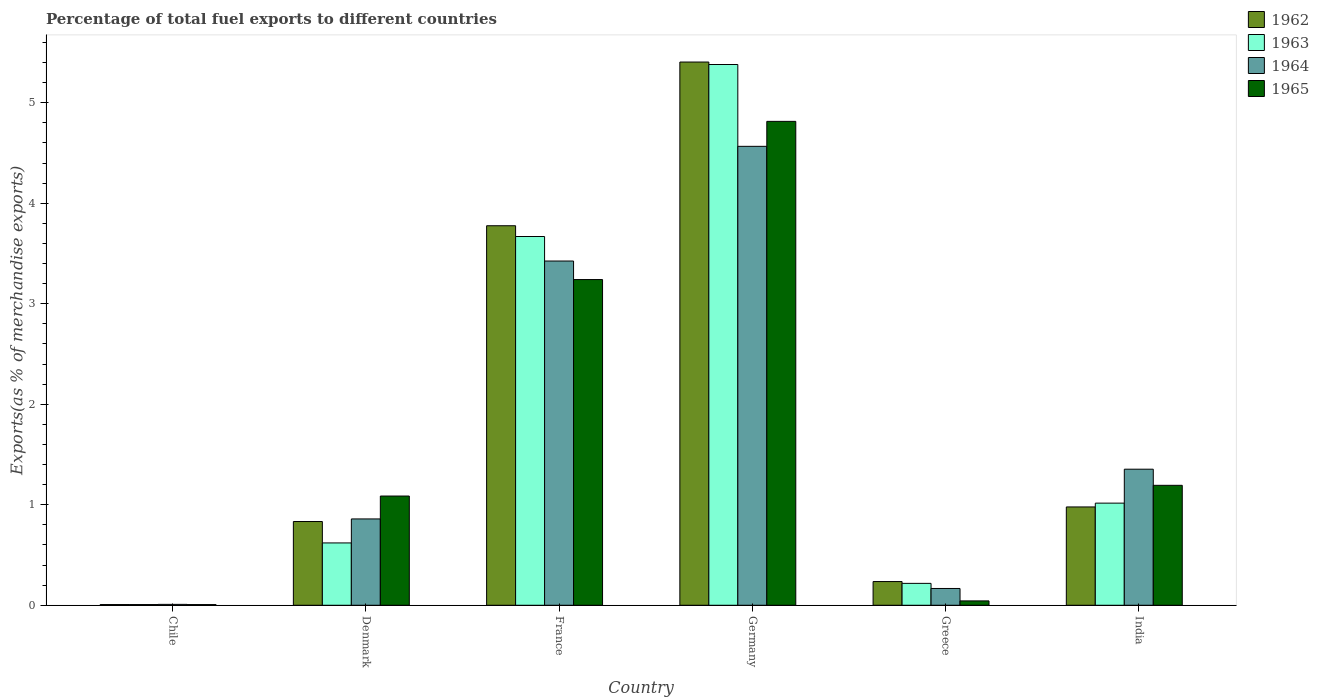How many groups of bars are there?
Provide a succinct answer. 6. Are the number of bars per tick equal to the number of legend labels?
Ensure brevity in your answer.  Yes. Are the number of bars on each tick of the X-axis equal?
Offer a very short reply. Yes. How many bars are there on the 1st tick from the left?
Give a very brief answer. 4. In how many cases, is the number of bars for a given country not equal to the number of legend labels?
Your answer should be compact. 0. What is the percentage of exports to different countries in 1965 in Denmark?
Make the answer very short. 1.09. Across all countries, what is the maximum percentage of exports to different countries in 1965?
Offer a very short reply. 4.81. Across all countries, what is the minimum percentage of exports to different countries in 1965?
Your response must be concise. 0.01. In which country was the percentage of exports to different countries in 1963 maximum?
Keep it short and to the point. Germany. What is the total percentage of exports to different countries in 1962 in the graph?
Keep it short and to the point. 11.24. What is the difference between the percentage of exports to different countries in 1964 in France and that in Greece?
Offer a terse response. 3.26. What is the difference between the percentage of exports to different countries in 1965 in Chile and the percentage of exports to different countries in 1962 in Germany?
Your answer should be compact. -5.4. What is the average percentage of exports to different countries in 1964 per country?
Offer a very short reply. 1.73. What is the difference between the percentage of exports to different countries of/in 1965 and percentage of exports to different countries of/in 1963 in Chile?
Keep it short and to the point. -0. In how many countries, is the percentage of exports to different countries in 1962 greater than 0.8 %?
Provide a succinct answer. 4. What is the ratio of the percentage of exports to different countries in 1962 in Denmark to that in France?
Ensure brevity in your answer.  0.22. Is the percentage of exports to different countries in 1965 in Greece less than that in India?
Make the answer very short. Yes. Is the difference between the percentage of exports to different countries in 1965 in France and India greater than the difference between the percentage of exports to different countries in 1963 in France and India?
Provide a succinct answer. No. What is the difference between the highest and the second highest percentage of exports to different countries in 1962?
Your answer should be compact. -2.8. What is the difference between the highest and the lowest percentage of exports to different countries in 1964?
Provide a succinct answer. 4.56. In how many countries, is the percentage of exports to different countries in 1965 greater than the average percentage of exports to different countries in 1965 taken over all countries?
Provide a succinct answer. 2. What does the 3rd bar from the left in India represents?
Provide a short and direct response. 1964. What does the 2nd bar from the right in Greece represents?
Keep it short and to the point. 1964. Are all the bars in the graph horizontal?
Offer a very short reply. No. How many countries are there in the graph?
Your answer should be very brief. 6. What is the difference between two consecutive major ticks on the Y-axis?
Your answer should be compact. 1. Are the values on the major ticks of Y-axis written in scientific E-notation?
Your response must be concise. No. Does the graph contain grids?
Your answer should be very brief. No. Where does the legend appear in the graph?
Ensure brevity in your answer.  Top right. What is the title of the graph?
Offer a terse response. Percentage of total fuel exports to different countries. What is the label or title of the Y-axis?
Keep it short and to the point. Exports(as % of merchandise exports). What is the Exports(as % of merchandise exports) of 1962 in Chile?
Keep it short and to the point. 0.01. What is the Exports(as % of merchandise exports) in 1963 in Chile?
Ensure brevity in your answer.  0.01. What is the Exports(as % of merchandise exports) in 1964 in Chile?
Give a very brief answer. 0.01. What is the Exports(as % of merchandise exports) in 1965 in Chile?
Give a very brief answer. 0.01. What is the Exports(as % of merchandise exports) of 1962 in Denmark?
Your answer should be compact. 0.83. What is the Exports(as % of merchandise exports) in 1963 in Denmark?
Give a very brief answer. 0.62. What is the Exports(as % of merchandise exports) of 1964 in Denmark?
Your answer should be compact. 0.86. What is the Exports(as % of merchandise exports) of 1965 in Denmark?
Make the answer very short. 1.09. What is the Exports(as % of merchandise exports) of 1962 in France?
Your answer should be compact. 3.78. What is the Exports(as % of merchandise exports) in 1963 in France?
Keep it short and to the point. 3.67. What is the Exports(as % of merchandise exports) of 1964 in France?
Your answer should be very brief. 3.43. What is the Exports(as % of merchandise exports) of 1965 in France?
Your answer should be compact. 3.24. What is the Exports(as % of merchandise exports) in 1962 in Germany?
Keep it short and to the point. 5.4. What is the Exports(as % of merchandise exports) in 1963 in Germany?
Offer a terse response. 5.38. What is the Exports(as % of merchandise exports) in 1964 in Germany?
Give a very brief answer. 4.57. What is the Exports(as % of merchandise exports) in 1965 in Germany?
Make the answer very short. 4.81. What is the Exports(as % of merchandise exports) of 1962 in Greece?
Offer a very short reply. 0.24. What is the Exports(as % of merchandise exports) in 1963 in Greece?
Offer a very short reply. 0.22. What is the Exports(as % of merchandise exports) of 1964 in Greece?
Keep it short and to the point. 0.17. What is the Exports(as % of merchandise exports) in 1965 in Greece?
Offer a terse response. 0.04. What is the Exports(as % of merchandise exports) in 1962 in India?
Ensure brevity in your answer.  0.98. What is the Exports(as % of merchandise exports) in 1963 in India?
Your answer should be compact. 1.02. What is the Exports(as % of merchandise exports) of 1964 in India?
Provide a succinct answer. 1.35. What is the Exports(as % of merchandise exports) in 1965 in India?
Make the answer very short. 1.19. Across all countries, what is the maximum Exports(as % of merchandise exports) in 1962?
Provide a short and direct response. 5.4. Across all countries, what is the maximum Exports(as % of merchandise exports) in 1963?
Provide a succinct answer. 5.38. Across all countries, what is the maximum Exports(as % of merchandise exports) in 1964?
Ensure brevity in your answer.  4.57. Across all countries, what is the maximum Exports(as % of merchandise exports) of 1965?
Offer a terse response. 4.81. Across all countries, what is the minimum Exports(as % of merchandise exports) in 1962?
Your response must be concise. 0.01. Across all countries, what is the minimum Exports(as % of merchandise exports) in 1963?
Make the answer very short. 0.01. Across all countries, what is the minimum Exports(as % of merchandise exports) of 1964?
Offer a very short reply. 0.01. Across all countries, what is the minimum Exports(as % of merchandise exports) of 1965?
Your response must be concise. 0.01. What is the total Exports(as % of merchandise exports) in 1962 in the graph?
Provide a short and direct response. 11.24. What is the total Exports(as % of merchandise exports) in 1963 in the graph?
Your response must be concise. 10.91. What is the total Exports(as % of merchandise exports) of 1964 in the graph?
Your answer should be very brief. 10.38. What is the total Exports(as % of merchandise exports) of 1965 in the graph?
Provide a succinct answer. 10.39. What is the difference between the Exports(as % of merchandise exports) of 1962 in Chile and that in Denmark?
Your answer should be compact. -0.83. What is the difference between the Exports(as % of merchandise exports) in 1963 in Chile and that in Denmark?
Ensure brevity in your answer.  -0.61. What is the difference between the Exports(as % of merchandise exports) in 1964 in Chile and that in Denmark?
Offer a very short reply. -0.85. What is the difference between the Exports(as % of merchandise exports) in 1965 in Chile and that in Denmark?
Keep it short and to the point. -1.08. What is the difference between the Exports(as % of merchandise exports) in 1962 in Chile and that in France?
Make the answer very short. -3.77. What is the difference between the Exports(as % of merchandise exports) in 1963 in Chile and that in France?
Your response must be concise. -3.66. What is the difference between the Exports(as % of merchandise exports) of 1964 in Chile and that in France?
Provide a short and direct response. -3.42. What is the difference between the Exports(as % of merchandise exports) in 1965 in Chile and that in France?
Give a very brief answer. -3.23. What is the difference between the Exports(as % of merchandise exports) in 1962 in Chile and that in Germany?
Provide a succinct answer. -5.4. What is the difference between the Exports(as % of merchandise exports) in 1963 in Chile and that in Germany?
Your response must be concise. -5.37. What is the difference between the Exports(as % of merchandise exports) in 1964 in Chile and that in Germany?
Provide a short and direct response. -4.56. What is the difference between the Exports(as % of merchandise exports) of 1965 in Chile and that in Germany?
Offer a very short reply. -4.81. What is the difference between the Exports(as % of merchandise exports) in 1962 in Chile and that in Greece?
Offer a very short reply. -0.23. What is the difference between the Exports(as % of merchandise exports) of 1963 in Chile and that in Greece?
Provide a short and direct response. -0.21. What is the difference between the Exports(as % of merchandise exports) of 1964 in Chile and that in Greece?
Provide a succinct answer. -0.16. What is the difference between the Exports(as % of merchandise exports) in 1965 in Chile and that in Greece?
Keep it short and to the point. -0.04. What is the difference between the Exports(as % of merchandise exports) in 1962 in Chile and that in India?
Your answer should be compact. -0.97. What is the difference between the Exports(as % of merchandise exports) of 1963 in Chile and that in India?
Your answer should be compact. -1.01. What is the difference between the Exports(as % of merchandise exports) in 1964 in Chile and that in India?
Your response must be concise. -1.34. What is the difference between the Exports(as % of merchandise exports) of 1965 in Chile and that in India?
Your answer should be very brief. -1.19. What is the difference between the Exports(as % of merchandise exports) in 1962 in Denmark and that in France?
Keep it short and to the point. -2.94. What is the difference between the Exports(as % of merchandise exports) in 1963 in Denmark and that in France?
Your response must be concise. -3.05. What is the difference between the Exports(as % of merchandise exports) of 1964 in Denmark and that in France?
Provide a short and direct response. -2.57. What is the difference between the Exports(as % of merchandise exports) in 1965 in Denmark and that in France?
Ensure brevity in your answer.  -2.15. What is the difference between the Exports(as % of merchandise exports) of 1962 in Denmark and that in Germany?
Offer a very short reply. -4.57. What is the difference between the Exports(as % of merchandise exports) of 1963 in Denmark and that in Germany?
Offer a very short reply. -4.76. What is the difference between the Exports(as % of merchandise exports) of 1964 in Denmark and that in Germany?
Give a very brief answer. -3.71. What is the difference between the Exports(as % of merchandise exports) of 1965 in Denmark and that in Germany?
Offer a very short reply. -3.73. What is the difference between the Exports(as % of merchandise exports) of 1962 in Denmark and that in Greece?
Your answer should be very brief. 0.6. What is the difference between the Exports(as % of merchandise exports) of 1963 in Denmark and that in Greece?
Your answer should be compact. 0.4. What is the difference between the Exports(as % of merchandise exports) in 1964 in Denmark and that in Greece?
Your response must be concise. 0.69. What is the difference between the Exports(as % of merchandise exports) of 1965 in Denmark and that in Greece?
Your answer should be very brief. 1.04. What is the difference between the Exports(as % of merchandise exports) of 1962 in Denmark and that in India?
Keep it short and to the point. -0.14. What is the difference between the Exports(as % of merchandise exports) in 1963 in Denmark and that in India?
Make the answer very short. -0.4. What is the difference between the Exports(as % of merchandise exports) in 1964 in Denmark and that in India?
Keep it short and to the point. -0.49. What is the difference between the Exports(as % of merchandise exports) of 1965 in Denmark and that in India?
Your response must be concise. -0.11. What is the difference between the Exports(as % of merchandise exports) in 1962 in France and that in Germany?
Provide a succinct answer. -1.63. What is the difference between the Exports(as % of merchandise exports) in 1963 in France and that in Germany?
Your answer should be compact. -1.71. What is the difference between the Exports(as % of merchandise exports) of 1964 in France and that in Germany?
Provide a short and direct response. -1.14. What is the difference between the Exports(as % of merchandise exports) in 1965 in France and that in Germany?
Your response must be concise. -1.57. What is the difference between the Exports(as % of merchandise exports) in 1962 in France and that in Greece?
Make the answer very short. 3.54. What is the difference between the Exports(as % of merchandise exports) in 1963 in France and that in Greece?
Provide a succinct answer. 3.45. What is the difference between the Exports(as % of merchandise exports) in 1964 in France and that in Greece?
Your response must be concise. 3.26. What is the difference between the Exports(as % of merchandise exports) in 1965 in France and that in Greece?
Your answer should be very brief. 3.2. What is the difference between the Exports(as % of merchandise exports) of 1962 in France and that in India?
Offer a terse response. 2.8. What is the difference between the Exports(as % of merchandise exports) in 1963 in France and that in India?
Provide a short and direct response. 2.65. What is the difference between the Exports(as % of merchandise exports) in 1964 in France and that in India?
Make the answer very short. 2.07. What is the difference between the Exports(as % of merchandise exports) in 1965 in France and that in India?
Make the answer very short. 2.05. What is the difference between the Exports(as % of merchandise exports) of 1962 in Germany and that in Greece?
Offer a very short reply. 5.17. What is the difference between the Exports(as % of merchandise exports) of 1963 in Germany and that in Greece?
Make the answer very short. 5.16. What is the difference between the Exports(as % of merchandise exports) of 1964 in Germany and that in Greece?
Keep it short and to the point. 4.4. What is the difference between the Exports(as % of merchandise exports) of 1965 in Germany and that in Greece?
Ensure brevity in your answer.  4.77. What is the difference between the Exports(as % of merchandise exports) in 1962 in Germany and that in India?
Give a very brief answer. 4.43. What is the difference between the Exports(as % of merchandise exports) in 1963 in Germany and that in India?
Give a very brief answer. 4.36. What is the difference between the Exports(as % of merchandise exports) in 1964 in Germany and that in India?
Your answer should be very brief. 3.21. What is the difference between the Exports(as % of merchandise exports) in 1965 in Germany and that in India?
Ensure brevity in your answer.  3.62. What is the difference between the Exports(as % of merchandise exports) of 1962 in Greece and that in India?
Make the answer very short. -0.74. What is the difference between the Exports(as % of merchandise exports) of 1963 in Greece and that in India?
Your response must be concise. -0.8. What is the difference between the Exports(as % of merchandise exports) in 1964 in Greece and that in India?
Provide a succinct answer. -1.19. What is the difference between the Exports(as % of merchandise exports) of 1965 in Greece and that in India?
Your response must be concise. -1.15. What is the difference between the Exports(as % of merchandise exports) of 1962 in Chile and the Exports(as % of merchandise exports) of 1963 in Denmark?
Make the answer very short. -0.61. What is the difference between the Exports(as % of merchandise exports) of 1962 in Chile and the Exports(as % of merchandise exports) of 1964 in Denmark?
Offer a very short reply. -0.85. What is the difference between the Exports(as % of merchandise exports) in 1962 in Chile and the Exports(as % of merchandise exports) in 1965 in Denmark?
Keep it short and to the point. -1.08. What is the difference between the Exports(as % of merchandise exports) in 1963 in Chile and the Exports(as % of merchandise exports) in 1964 in Denmark?
Give a very brief answer. -0.85. What is the difference between the Exports(as % of merchandise exports) in 1963 in Chile and the Exports(as % of merchandise exports) in 1965 in Denmark?
Your answer should be compact. -1.08. What is the difference between the Exports(as % of merchandise exports) of 1964 in Chile and the Exports(as % of merchandise exports) of 1965 in Denmark?
Your response must be concise. -1.08. What is the difference between the Exports(as % of merchandise exports) of 1962 in Chile and the Exports(as % of merchandise exports) of 1963 in France?
Your response must be concise. -3.66. What is the difference between the Exports(as % of merchandise exports) in 1962 in Chile and the Exports(as % of merchandise exports) in 1964 in France?
Your answer should be compact. -3.42. What is the difference between the Exports(as % of merchandise exports) of 1962 in Chile and the Exports(as % of merchandise exports) of 1965 in France?
Your answer should be very brief. -3.23. What is the difference between the Exports(as % of merchandise exports) in 1963 in Chile and the Exports(as % of merchandise exports) in 1964 in France?
Your response must be concise. -3.42. What is the difference between the Exports(as % of merchandise exports) of 1963 in Chile and the Exports(as % of merchandise exports) of 1965 in France?
Offer a very short reply. -3.23. What is the difference between the Exports(as % of merchandise exports) in 1964 in Chile and the Exports(as % of merchandise exports) in 1965 in France?
Give a very brief answer. -3.23. What is the difference between the Exports(as % of merchandise exports) in 1962 in Chile and the Exports(as % of merchandise exports) in 1963 in Germany?
Provide a short and direct response. -5.37. What is the difference between the Exports(as % of merchandise exports) of 1962 in Chile and the Exports(as % of merchandise exports) of 1964 in Germany?
Keep it short and to the point. -4.56. What is the difference between the Exports(as % of merchandise exports) in 1962 in Chile and the Exports(as % of merchandise exports) in 1965 in Germany?
Ensure brevity in your answer.  -4.81. What is the difference between the Exports(as % of merchandise exports) in 1963 in Chile and the Exports(as % of merchandise exports) in 1964 in Germany?
Make the answer very short. -4.56. What is the difference between the Exports(as % of merchandise exports) in 1963 in Chile and the Exports(as % of merchandise exports) in 1965 in Germany?
Offer a very short reply. -4.81. What is the difference between the Exports(as % of merchandise exports) in 1964 in Chile and the Exports(as % of merchandise exports) in 1965 in Germany?
Keep it short and to the point. -4.81. What is the difference between the Exports(as % of merchandise exports) in 1962 in Chile and the Exports(as % of merchandise exports) in 1963 in Greece?
Your answer should be very brief. -0.21. What is the difference between the Exports(as % of merchandise exports) in 1962 in Chile and the Exports(as % of merchandise exports) in 1964 in Greece?
Ensure brevity in your answer.  -0.16. What is the difference between the Exports(as % of merchandise exports) of 1962 in Chile and the Exports(as % of merchandise exports) of 1965 in Greece?
Give a very brief answer. -0.04. What is the difference between the Exports(as % of merchandise exports) in 1963 in Chile and the Exports(as % of merchandise exports) in 1964 in Greece?
Make the answer very short. -0.16. What is the difference between the Exports(as % of merchandise exports) in 1963 in Chile and the Exports(as % of merchandise exports) in 1965 in Greece?
Your response must be concise. -0.04. What is the difference between the Exports(as % of merchandise exports) in 1964 in Chile and the Exports(as % of merchandise exports) in 1965 in Greece?
Ensure brevity in your answer.  -0.03. What is the difference between the Exports(as % of merchandise exports) of 1962 in Chile and the Exports(as % of merchandise exports) of 1963 in India?
Provide a short and direct response. -1.01. What is the difference between the Exports(as % of merchandise exports) of 1962 in Chile and the Exports(as % of merchandise exports) of 1964 in India?
Provide a succinct answer. -1.35. What is the difference between the Exports(as % of merchandise exports) of 1962 in Chile and the Exports(as % of merchandise exports) of 1965 in India?
Provide a succinct answer. -1.19. What is the difference between the Exports(as % of merchandise exports) of 1963 in Chile and the Exports(as % of merchandise exports) of 1964 in India?
Your answer should be compact. -1.35. What is the difference between the Exports(as % of merchandise exports) in 1963 in Chile and the Exports(as % of merchandise exports) in 1965 in India?
Your response must be concise. -1.19. What is the difference between the Exports(as % of merchandise exports) of 1964 in Chile and the Exports(as % of merchandise exports) of 1965 in India?
Your answer should be compact. -1.18. What is the difference between the Exports(as % of merchandise exports) of 1962 in Denmark and the Exports(as % of merchandise exports) of 1963 in France?
Your response must be concise. -2.84. What is the difference between the Exports(as % of merchandise exports) in 1962 in Denmark and the Exports(as % of merchandise exports) in 1964 in France?
Offer a terse response. -2.59. What is the difference between the Exports(as % of merchandise exports) in 1962 in Denmark and the Exports(as % of merchandise exports) in 1965 in France?
Keep it short and to the point. -2.41. What is the difference between the Exports(as % of merchandise exports) of 1963 in Denmark and the Exports(as % of merchandise exports) of 1964 in France?
Give a very brief answer. -2.8. What is the difference between the Exports(as % of merchandise exports) in 1963 in Denmark and the Exports(as % of merchandise exports) in 1965 in France?
Offer a very short reply. -2.62. What is the difference between the Exports(as % of merchandise exports) of 1964 in Denmark and the Exports(as % of merchandise exports) of 1965 in France?
Offer a very short reply. -2.38. What is the difference between the Exports(as % of merchandise exports) of 1962 in Denmark and the Exports(as % of merchandise exports) of 1963 in Germany?
Your answer should be very brief. -4.55. What is the difference between the Exports(as % of merchandise exports) in 1962 in Denmark and the Exports(as % of merchandise exports) in 1964 in Germany?
Make the answer very short. -3.73. What is the difference between the Exports(as % of merchandise exports) in 1962 in Denmark and the Exports(as % of merchandise exports) in 1965 in Germany?
Provide a succinct answer. -3.98. What is the difference between the Exports(as % of merchandise exports) in 1963 in Denmark and the Exports(as % of merchandise exports) in 1964 in Germany?
Provide a succinct answer. -3.95. What is the difference between the Exports(as % of merchandise exports) of 1963 in Denmark and the Exports(as % of merchandise exports) of 1965 in Germany?
Your answer should be compact. -4.19. What is the difference between the Exports(as % of merchandise exports) in 1964 in Denmark and the Exports(as % of merchandise exports) in 1965 in Germany?
Your answer should be very brief. -3.96. What is the difference between the Exports(as % of merchandise exports) of 1962 in Denmark and the Exports(as % of merchandise exports) of 1963 in Greece?
Your response must be concise. 0.62. What is the difference between the Exports(as % of merchandise exports) in 1962 in Denmark and the Exports(as % of merchandise exports) in 1964 in Greece?
Keep it short and to the point. 0.67. What is the difference between the Exports(as % of merchandise exports) in 1962 in Denmark and the Exports(as % of merchandise exports) in 1965 in Greece?
Keep it short and to the point. 0.79. What is the difference between the Exports(as % of merchandise exports) of 1963 in Denmark and the Exports(as % of merchandise exports) of 1964 in Greece?
Offer a very short reply. 0.45. What is the difference between the Exports(as % of merchandise exports) in 1963 in Denmark and the Exports(as % of merchandise exports) in 1965 in Greece?
Provide a short and direct response. 0.58. What is the difference between the Exports(as % of merchandise exports) of 1964 in Denmark and the Exports(as % of merchandise exports) of 1965 in Greece?
Give a very brief answer. 0.82. What is the difference between the Exports(as % of merchandise exports) in 1962 in Denmark and the Exports(as % of merchandise exports) in 1963 in India?
Ensure brevity in your answer.  -0.18. What is the difference between the Exports(as % of merchandise exports) in 1962 in Denmark and the Exports(as % of merchandise exports) in 1964 in India?
Offer a terse response. -0.52. What is the difference between the Exports(as % of merchandise exports) of 1962 in Denmark and the Exports(as % of merchandise exports) of 1965 in India?
Give a very brief answer. -0.36. What is the difference between the Exports(as % of merchandise exports) in 1963 in Denmark and the Exports(as % of merchandise exports) in 1964 in India?
Make the answer very short. -0.73. What is the difference between the Exports(as % of merchandise exports) of 1963 in Denmark and the Exports(as % of merchandise exports) of 1965 in India?
Keep it short and to the point. -0.57. What is the difference between the Exports(as % of merchandise exports) in 1964 in Denmark and the Exports(as % of merchandise exports) in 1965 in India?
Your response must be concise. -0.33. What is the difference between the Exports(as % of merchandise exports) of 1962 in France and the Exports(as % of merchandise exports) of 1963 in Germany?
Ensure brevity in your answer.  -1.6. What is the difference between the Exports(as % of merchandise exports) in 1962 in France and the Exports(as % of merchandise exports) in 1964 in Germany?
Ensure brevity in your answer.  -0.79. What is the difference between the Exports(as % of merchandise exports) of 1962 in France and the Exports(as % of merchandise exports) of 1965 in Germany?
Offer a very short reply. -1.04. What is the difference between the Exports(as % of merchandise exports) in 1963 in France and the Exports(as % of merchandise exports) in 1964 in Germany?
Your answer should be compact. -0.9. What is the difference between the Exports(as % of merchandise exports) of 1963 in France and the Exports(as % of merchandise exports) of 1965 in Germany?
Keep it short and to the point. -1.15. What is the difference between the Exports(as % of merchandise exports) in 1964 in France and the Exports(as % of merchandise exports) in 1965 in Germany?
Provide a succinct answer. -1.39. What is the difference between the Exports(as % of merchandise exports) in 1962 in France and the Exports(as % of merchandise exports) in 1963 in Greece?
Your answer should be very brief. 3.56. What is the difference between the Exports(as % of merchandise exports) of 1962 in France and the Exports(as % of merchandise exports) of 1964 in Greece?
Give a very brief answer. 3.61. What is the difference between the Exports(as % of merchandise exports) of 1962 in France and the Exports(as % of merchandise exports) of 1965 in Greece?
Offer a terse response. 3.73. What is the difference between the Exports(as % of merchandise exports) in 1963 in France and the Exports(as % of merchandise exports) in 1964 in Greece?
Offer a terse response. 3.5. What is the difference between the Exports(as % of merchandise exports) in 1963 in France and the Exports(as % of merchandise exports) in 1965 in Greece?
Your answer should be compact. 3.63. What is the difference between the Exports(as % of merchandise exports) in 1964 in France and the Exports(as % of merchandise exports) in 1965 in Greece?
Your answer should be very brief. 3.38. What is the difference between the Exports(as % of merchandise exports) of 1962 in France and the Exports(as % of merchandise exports) of 1963 in India?
Make the answer very short. 2.76. What is the difference between the Exports(as % of merchandise exports) in 1962 in France and the Exports(as % of merchandise exports) in 1964 in India?
Keep it short and to the point. 2.42. What is the difference between the Exports(as % of merchandise exports) in 1962 in France and the Exports(as % of merchandise exports) in 1965 in India?
Make the answer very short. 2.58. What is the difference between the Exports(as % of merchandise exports) in 1963 in France and the Exports(as % of merchandise exports) in 1964 in India?
Your answer should be very brief. 2.32. What is the difference between the Exports(as % of merchandise exports) in 1963 in France and the Exports(as % of merchandise exports) in 1965 in India?
Your answer should be very brief. 2.48. What is the difference between the Exports(as % of merchandise exports) of 1964 in France and the Exports(as % of merchandise exports) of 1965 in India?
Your response must be concise. 2.23. What is the difference between the Exports(as % of merchandise exports) of 1962 in Germany and the Exports(as % of merchandise exports) of 1963 in Greece?
Make the answer very short. 5.19. What is the difference between the Exports(as % of merchandise exports) of 1962 in Germany and the Exports(as % of merchandise exports) of 1964 in Greece?
Make the answer very short. 5.24. What is the difference between the Exports(as % of merchandise exports) in 1962 in Germany and the Exports(as % of merchandise exports) in 1965 in Greece?
Keep it short and to the point. 5.36. What is the difference between the Exports(as % of merchandise exports) of 1963 in Germany and the Exports(as % of merchandise exports) of 1964 in Greece?
Provide a short and direct response. 5.21. What is the difference between the Exports(as % of merchandise exports) in 1963 in Germany and the Exports(as % of merchandise exports) in 1965 in Greece?
Your answer should be very brief. 5.34. What is the difference between the Exports(as % of merchandise exports) in 1964 in Germany and the Exports(as % of merchandise exports) in 1965 in Greece?
Provide a succinct answer. 4.52. What is the difference between the Exports(as % of merchandise exports) in 1962 in Germany and the Exports(as % of merchandise exports) in 1963 in India?
Give a very brief answer. 4.39. What is the difference between the Exports(as % of merchandise exports) in 1962 in Germany and the Exports(as % of merchandise exports) in 1964 in India?
Give a very brief answer. 4.05. What is the difference between the Exports(as % of merchandise exports) of 1962 in Germany and the Exports(as % of merchandise exports) of 1965 in India?
Offer a very short reply. 4.21. What is the difference between the Exports(as % of merchandise exports) in 1963 in Germany and the Exports(as % of merchandise exports) in 1964 in India?
Your answer should be compact. 4.03. What is the difference between the Exports(as % of merchandise exports) in 1963 in Germany and the Exports(as % of merchandise exports) in 1965 in India?
Keep it short and to the point. 4.19. What is the difference between the Exports(as % of merchandise exports) in 1964 in Germany and the Exports(as % of merchandise exports) in 1965 in India?
Provide a succinct answer. 3.37. What is the difference between the Exports(as % of merchandise exports) of 1962 in Greece and the Exports(as % of merchandise exports) of 1963 in India?
Keep it short and to the point. -0.78. What is the difference between the Exports(as % of merchandise exports) in 1962 in Greece and the Exports(as % of merchandise exports) in 1964 in India?
Your response must be concise. -1.12. What is the difference between the Exports(as % of merchandise exports) of 1962 in Greece and the Exports(as % of merchandise exports) of 1965 in India?
Keep it short and to the point. -0.96. What is the difference between the Exports(as % of merchandise exports) of 1963 in Greece and the Exports(as % of merchandise exports) of 1964 in India?
Provide a succinct answer. -1.14. What is the difference between the Exports(as % of merchandise exports) of 1963 in Greece and the Exports(as % of merchandise exports) of 1965 in India?
Your answer should be compact. -0.98. What is the difference between the Exports(as % of merchandise exports) of 1964 in Greece and the Exports(as % of merchandise exports) of 1965 in India?
Ensure brevity in your answer.  -1.03. What is the average Exports(as % of merchandise exports) in 1962 per country?
Provide a succinct answer. 1.87. What is the average Exports(as % of merchandise exports) of 1963 per country?
Provide a short and direct response. 1.82. What is the average Exports(as % of merchandise exports) of 1964 per country?
Provide a short and direct response. 1.73. What is the average Exports(as % of merchandise exports) of 1965 per country?
Provide a short and direct response. 1.73. What is the difference between the Exports(as % of merchandise exports) in 1962 and Exports(as % of merchandise exports) in 1963 in Chile?
Your answer should be very brief. -0. What is the difference between the Exports(as % of merchandise exports) in 1962 and Exports(as % of merchandise exports) in 1964 in Chile?
Your answer should be compact. -0. What is the difference between the Exports(as % of merchandise exports) of 1963 and Exports(as % of merchandise exports) of 1964 in Chile?
Offer a very short reply. -0. What is the difference between the Exports(as % of merchandise exports) of 1964 and Exports(as % of merchandise exports) of 1965 in Chile?
Offer a very short reply. 0. What is the difference between the Exports(as % of merchandise exports) in 1962 and Exports(as % of merchandise exports) in 1963 in Denmark?
Keep it short and to the point. 0.21. What is the difference between the Exports(as % of merchandise exports) in 1962 and Exports(as % of merchandise exports) in 1964 in Denmark?
Offer a terse response. -0.03. What is the difference between the Exports(as % of merchandise exports) of 1962 and Exports(as % of merchandise exports) of 1965 in Denmark?
Keep it short and to the point. -0.25. What is the difference between the Exports(as % of merchandise exports) of 1963 and Exports(as % of merchandise exports) of 1964 in Denmark?
Offer a very short reply. -0.24. What is the difference between the Exports(as % of merchandise exports) of 1963 and Exports(as % of merchandise exports) of 1965 in Denmark?
Offer a terse response. -0.47. What is the difference between the Exports(as % of merchandise exports) of 1964 and Exports(as % of merchandise exports) of 1965 in Denmark?
Keep it short and to the point. -0.23. What is the difference between the Exports(as % of merchandise exports) of 1962 and Exports(as % of merchandise exports) of 1963 in France?
Offer a terse response. 0.11. What is the difference between the Exports(as % of merchandise exports) in 1962 and Exports(as % of merchandise exports) in 1964 in France?
Keep it short and to the point. 0.35. What is the difference between the Exports(as % of merchandise exports) of 1962 and Exports(as % of merchandise exports) of 1965 in France?
Ensure brevity in your answer.  0.54. What is the difference between the Exports(as % of merchandise exports) in 1963 and Exports(as % of merchandise exports) in 1964 in France?
Provide a short and direct response. 0.24. What is the difference between the Exports(as % of merchandise exports) of 1963 and Exports(as % of merchandise exports) of 1965 in France?
Your response must be concise. 0.43. What is the difference between the Exports(as % of merchandise exports) in 1964 and Exports(as % of merchandise exports) in 1965 in France?
Provide a short and direct response. 0.18. What is the difference between the Exports(as % of merchandise exports) of 1962 and Exports(as % of merchandise exports) of 1963 in Germany?
Provide a succinct answer. 0.02. What is the difference between the Exports(as % of merchandise exports) of 1962 and Exports(as % of merchandise exports) of 1964 in Germany?
Ensure brevity in your answer.  0.84. What is the difference between the Exports(as % of merchandise exports) of 1962 and Exports(as % of merchandise exports) of 1965 in Germany?
Give a very brief answer. 0.59. What is the difference between the Exports(as % of merchandise exports) in 1963 and Exports(as % of merchandise exports) in 1964 in Germany?
Your answer should be very brief. 0.81. What is the difference between the Exports(as % of merchandise exports) in 1963 and Exports(as % of merchandise exports) in 1965 in Germany?
Make the answer very short. 0.57. What is the difference between the Exports(as % of merchandise exports) of 1964 and Exports(as % of merchandise exports) of 1965 in Germany?
Keep it short and to the point. -0.25. What is the difference between the Exports(as % of merchandise exports) of 1962 and Exports(as % of merchandise exports) of 1963 in Greece?
Give a very brief answer. 0.02. What is the difference between the Exports(as % of merchandise exports) of 1962 and Exports(as % of merchandise exports) of 1964 in Greece?
Your response must be concise. 0.07. What is the difference between the Exports(as % of merchandise exports) of 1962 and Exports(as % of merchandise exports) of 1965 in Greece?
Offer a very short reply. 0.19. What is the difference between the Exports(as % of merchandise exports) in 1963 and Exports(as % of merchandise exports) in 1964 in Greece?
Ensure brevity in your answer.  0.05. What is the difference between the Exports(as % of merchandise exports) of 1963 and Exports(as % of merchandise exports) of 1965 in Greece?
Keep it short and to the point. 0.17. What is the difference between the Exports(as % of merchandise exports) in 1964 and Exports(as % of merchandise exports) in 1965 in Greece?
Keep it short and to the point. 0.12. What is the difference between the Exports(as % of merchandise exports) in 1962 and Exports(as % of merchandise exports) in 1963 in India?
Provide a short and direct response. -0.04. What is the difference between the Exports(as % of merchandise exports) in 1962 and Exports(as % of merchandise exports) in 1964 in India?
Offer a very short reply. -0.38. What is the difference between the Exports(as % of merchandise exports) of 1962 and Exports(as % of merchandise exports) of 1965 in India?
Provide a succinct answer. -0.22. What is the difference between the Exports(as % of merchandise exports) in 1963 and Exports(as % of merchandise exports) in 1964 in India?
Your answer should be compact. -0.34. What is the difference between the Exports(as % of merchandise exports) in 1963 and Exports(as % of merchandise exports) in 1965 in India?
Provide a succinct answer. -0.18. What is the difference between the Exports(as % of merchandise exports) in 1964 and Exports(as % of merchandise exports) in 1965 in India?
Your answer should be very brief. 0.16. What is the ratio of the Exports(as % of merchandise exports) of 1962 in Chile to that in Denmark?
Your response must be concise. 0.01. What is the ratio of the Exports(as % of merchandise exports) of 1963 in Chile to that in Denmark?
Offer a very short reply. 0.01. What is the ratio of the Exports(as % of merchandise exports) in 1964 in Chile to that in Denmark?
Provide a succinct answer. 0.01. What is the ratio of the Exports(as % of merchandise exports) in 1965 in Chile to that in Denmark?
Ensure brevity in your answer.  0.01. What is the ratio of the Exports(as % of merchandise exports) in 1962 in Chile to that in France?
Make the answer very short. 0. What is the ratio of the Exports(as % of merchandise exports) of 1963 in Chile to that in France?
Give a very brief answer. 0. What is the ratio of the Exports(as % of merchandise exports) in 1964 in Chile to that in France?
Your answer should be compact. 0. What is the ratio of the Exports(as % of merchandise exports) of 1965 in Chile to that in France?
Offer a very short reply. 0. What is the ratio of the Exports(as % of merchandise exports) in 1962 in Chile to that in Germany?
Your answer should be very brief. 0. What is the ratio of the Exports(as % of merchandise exports) of 1963 in Chile to that in Germany?
Ensure brevity in your answer.  0. What is the ratio of the Exports(as % of merchandise exports) of 1964 in Chile to that in Germany?
Provide a succinct answer. 0. What is the ratio of the Exports(as % of merchandise exports) in 1965 in Chile to that in Germany?
Offer a very short reply. 0. What is the ratio of the Exports(as % of merchandise exports) of 1962 in Chile to that in Greece?
Your answer should be very brief. 0.03. What is the ratio of the Exports(as % of merchandise exports) in 1963 in Chile to that in Greece?
Keep it short and to the point. 0.03. What is the ratio of the Exports(as % of merchandise exports) of 1964 in Chile to that in Greece?
Your response must be concise. 0.05. What is the ratio of the Exports(as % of merchandise exports) in 1965 in Chile to that in Greece?
Provide a short and direct response. 0.16. What is the ratio of the Exports(as % of merchandise exports) of 1962 in Chile to that in India?
Give a very brief answer. 0.01. What is the ratio of the Exports(as % of merchandise exports) of 1963 in Chile to that in India?
Ensure brevity in your answer.  0.01. What is the ratio of the Exports(as % of merchandise exports) in 1964 in Chile to that in India?
Your response must be concise. 0.01. What is the ratio of the Exports(as % of merchandise exports) of 1965 in Chile to that in India?
Provide a succinct answer. 0.01. What is the ratio of the Exports(as % of merchandise exports) in 1962 in Denmark to that in France?
Make the answer very short. 0.22. What is the ratio of the Exports(as % of merchandise exports) of 1963 in Denmark to that in France?
Offer a terse response. 0.17. What is the ratio of the Exports(as % of merchandise exports) in 1964 in Denmark to that in France?
Make the answer very short. 0.25. What is the ratio of the Exports(as % of merchandise exports) in 1965 in Denmark to that in France?
Provide a short and direct response. 0.34. What is the ratio of the Exports(as % of merchandise exports) of 1962 in Denmark to that in Germany?
Offer a very short reply. 0.15. What is the ratio of the Exports(as % of merchandise exports) in 1963 in Denmark to that in Germany?
Keep it short and to the point. 0.12. What is the ratio of the Exports(as % of merchandise exports) in 1964 in Denmark to that in Germany?
Provide a short and direct response. 0.19. What is the ratio of the Exports(as % of merchandise exports) of 1965 in Denmark to that in Germany?
Your answer should be compact. 0.23. What is the ratio of the Exports(as % of merchandise exports) in 1962 in Denmark to that in Greece?
Your answer should be compact. 3.53. What is the ratio of the Exports(as % of merchandise exports) in 1963 in Denmark to that in Greece?
Provide a short and direct response. 2.85. What is the ratio of the Exports(as % of merchandise exports) in 1964 in Denmark to that in Greece?
Provide a short and direct response. 5.14. What is the ratio of the Exports(as % of merchandise exports) of 1965 in Denmark to that in Greece?
Offer a terse response. 25.05. What is the ratio of the Exports(as % of merchandise exports) of 1962 in Denmark to that in India?
Make the answer very short. 0.85. What is the ratio of the Exports(as % of merchandise exports) of 1963 in Denmark to that in India?
Provide a succinct answer. 0.61. What is the ratio of the Exports(as % of merchandise exports) in 1964 in Denmark to that in India?
Offer a very short reply. 0.63. What is the ratio of the Exports(as % of merchandise exports) in 1965 in Denmark to that in India?
Provide a succinct answer. 0.91. What is the ratio of the Exports(as % of merchandise exports) in 1962 in France to that in Germany?
Keep it short and to the point. 0.7. What is the ratio of the Exports(as % of merchandise exports) of 1963 in France to that in Germany?
Provide a succinct answer. 0.68. What is the ratio of the Exports(as % of merchandise exports) of 1964 in France to that in Germany?
Ensure brevity in your answer.  0.75. What is the ratio of the Exports(as % of merchandise exports) of 1965 in France to that in Germany?
Provide a short and direct response. 0.67. What is the ratio of the Exports(as % of merchandise exports) in 1962 in France to that in Greece?
Ensure brevity in your answer.  16.01. What is the ratio of the Exports(as % of merchandise exports) in 1963 in France to that in Greece?
Your answer should be compact. 16.85. What is the ratio of the Exports(as % of merchandise exports) in 1964 in France to that in Greece?
Keep it short and to the point. 20.5. What is the ratio of the Exports(as % of merchandise exports) of 1965 in France to that in Greece?
Your answer should be very brief. 74.69. What is the ratio of the Exports(as % of merchandise exports) in 1962 in France to that in India?
Offer a terse response. 3.86. What is the ratio of the Exports(as % of merchandise exports) of 1963 in France to that in India?
Keep it short and to the point. 3.61. What is the ratio of the Exports(as % of merchandise exports) of 1964 in France to that in India?
Ensure brevity in your answer.  2.53. What is the ratio of the Exports(as % of merchandise exports) in 1965 in France to that in India?
Offer a very short reply. 2.72. What is the ratio of the Exports(as % of merchandise exports) in 1962 in Germany to that in Greece?
Your response must be concise. 22.91. What is the ratio of the Exports(as % of merchandise exports) in 1963 in Germany to that in Greece?
Ensure brevity in your answer.  24.71. What is the ratio of the Exports(as % of merchandise exports) of 1964 in Germany to that in Greece?
Give a very brief answer. 27.34. What is the ratio of the Exports(as % of merchandise exports) of 1965 in Germany to that in Greece?
Provide a short and direct response. 110.96. What is the ratio of the Exports(as % of merchandise exports) of 1962 in Germany to that in India?
Provide a short and direct response. 5.53. What is the ratio of the Exports(as % of merchandise exports) of 1963 in Germany to that in India?
Your answer should be compact. 5.3. What is the ratio of the Exports(as % of merchandise exports) in 1964 in Germany to that in India?
Keep it short and to the point. 3.37. What is the ratio of the Exports(as % of merchandise exports) in 1965 in Germany to that in India?
Give a very brief answer. 4.03. What is the ratio of the Exports(as % of merchandise exports) of 1962 in Greece to that in India?
Your response must be concise. 0.24. What is the ratio of the Exports(as % of merchandise exports) of 1963 in Greece to that in India?
Provide a succinct answer. 0.21. What is the ratio of the Exports(as % of merchandise exports) in 1964 in Greece to that in India?
Make the answer very short. 0.12. What is the ratio of the Exports(as % of merchandise exports) of 1965 in Greece to that in India?
Your answer should be very brief. 0.04. What is the difference between the highest and the second highest Exports(as % of merchandise exports) of 1962?
Your response must be concise. 1.63. What is the difference between the highest and the second highest Exports(as % of merchandise exports) of 1963?
Offer a very short reply. 1.71. What is the difference between the highest and the second highest Exports(as % of merchandise exports) in 1964?
Provide a short and direct response. 1.14. What is the difference between the highest and the second highest Exports(as % of merchandise exports) of 1965?
Your answer should be compact. 1.57. What is the difference between the highest and the lowest Exports(as % of merchandise exports) in 1962?
Keep it short and to the point. 5.4. What is the difference between the highest and the lowest Exports(as % of merchandise exports) in 1963?
Offer a very short reply. 5.37. What is the difference between the highest and the lowest Exports(as % of merchandise exports) of 1964?
Offer a terse response. 4.56. What is the difference between the highest and the lowest Exports(as % of merchandise exports) of 1965?
Offer a terse response. 4.81. 